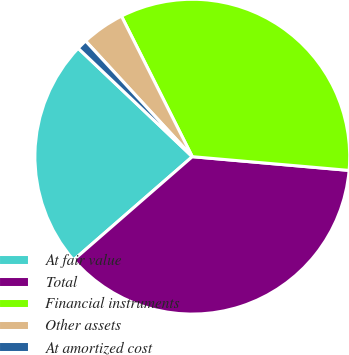Convert chart to OTSL. <chart><loc_0><loc_0><loc_500><loc_500><pie_chart><fcel>At fair value<fcel>Total<fcel>Financial instruments<fcel>Other assets<fcel>At amortized cost<nl><fcel>23.49%<fcel>37.21%<fcel>33.82%<fcel>4.43%<fcel>1.05%<nl></chart> 